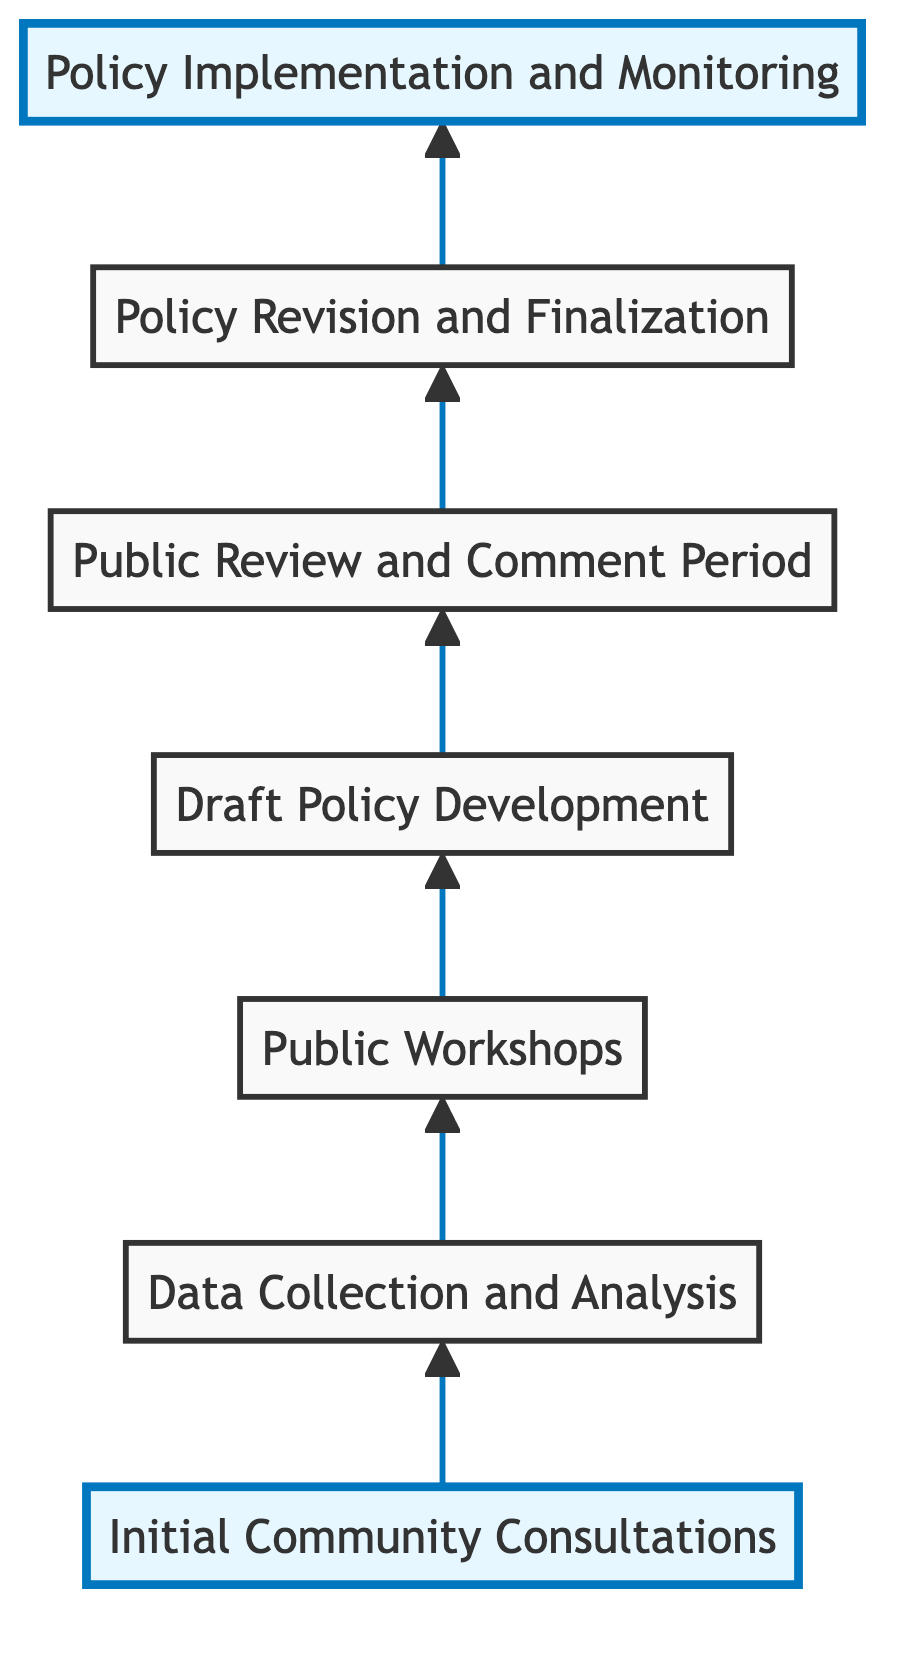What is the first step in the community feedback process? The diagram indicates that the process begins with "Initial Community Consultations," which is the first node at the bottom of the flow chart.
Answer: Initial Community Consultations How many steps are there in the diagram? The diagram consists of seven distinct nodes, each representing a step in the community feedback process.
Answer: Seven What follows after "Data Collection and Analysis"? The flow chart outlines the process, and the node immediately following "Data Collection and Analysis" is "Public Workshops." This indicates the sequence of activities in the community feedback process.
Answer: Public Workshops What is the final step in implementing the policy? The final step, shown at the top of the flow chart, is "Policy Implementation and Monitoring," which signifies the last action taken in the process.
Answer: Policy Implementation and Monitoring Which step involves gathering public opinions on draft policies? The node labeled "Public Review and Comment Period" indicates the phase where community members can provide additional feedback on the draft policies.
Answer: Public Review and Comment Period What is the relationship between "Public Workshops" and "Draft Policy Development"? "Public Workshops" precedes "Draft Policy Development" in the diagram, suggesting that insights gathered from the workshops inform the development of the draft policies.
Answer: Public Workshops precedes Draft Policy Development What happens after the "Policy Revision and Finalization"? According to the diagram's flow, the step that follows "Policy Revision and Finalization" is "Policy Implementation and Monitoring," indicating that the revised policies are then put into action.
Answer: Policy Implementation and Monitoring 